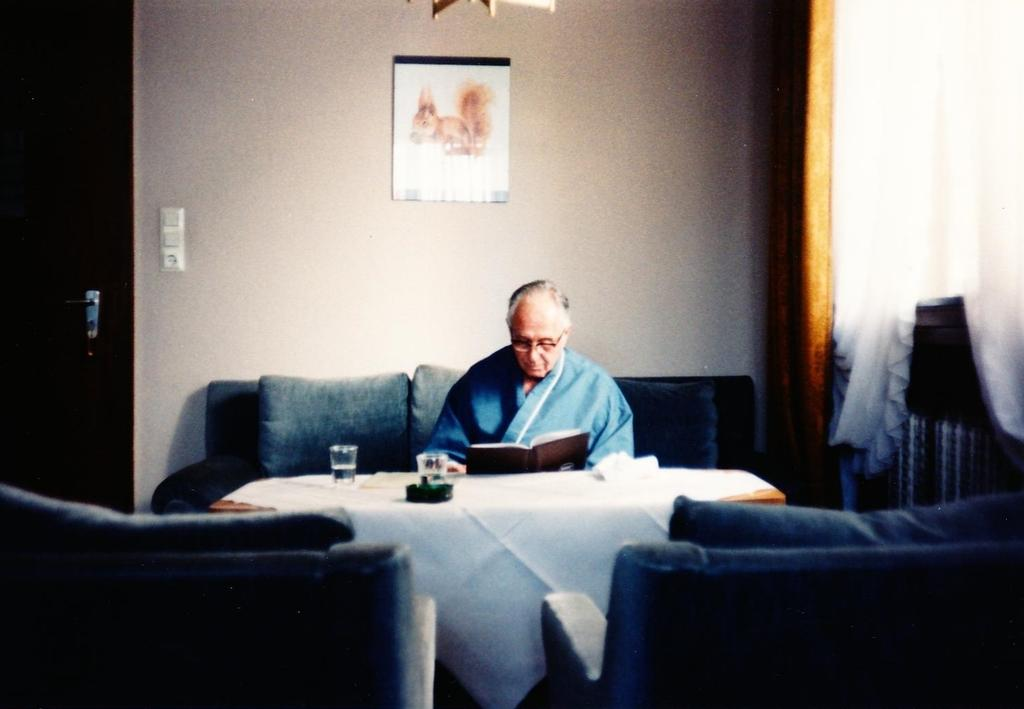What is the person in the image doing? The person is sitting in the image. Where is the person sitting in relation to other objects? The person is sitting in front of a table. What can be seen on the table in the image? There is a glass on the table. What is visible in the background of the image? There is a paper attached to the wall in the background. What type of nut is being discussed by the person in the image? There is no indication in the image that a nut is being discussed, nor is there any conversation taking place. 